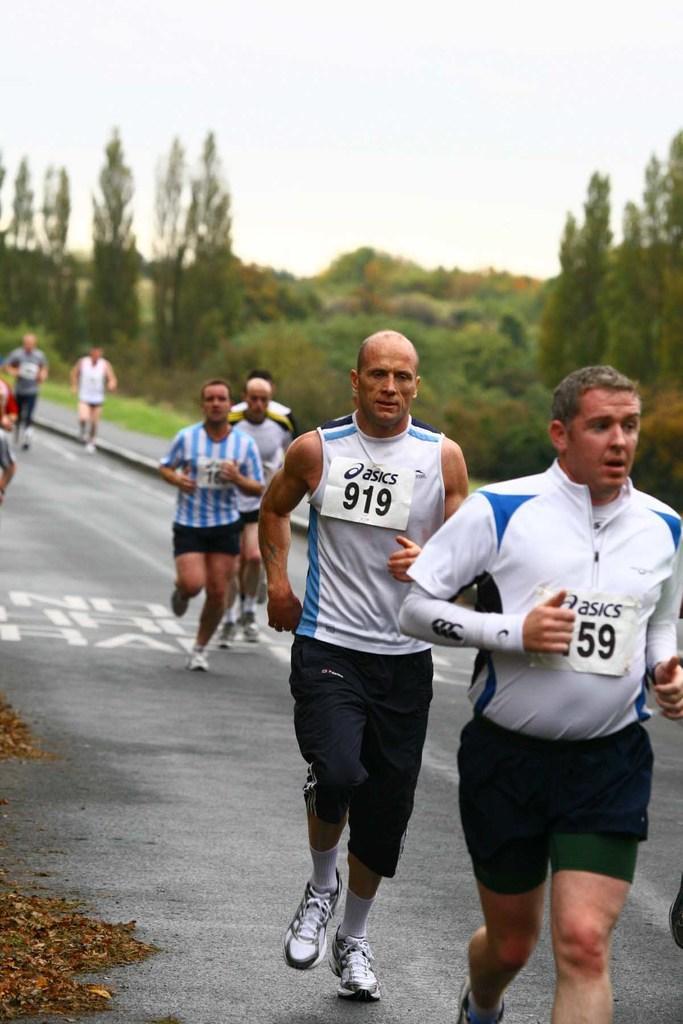Could you give a brief overview of what you see in this image? People are running on the road. In the background we can see trees, plants and sky. 